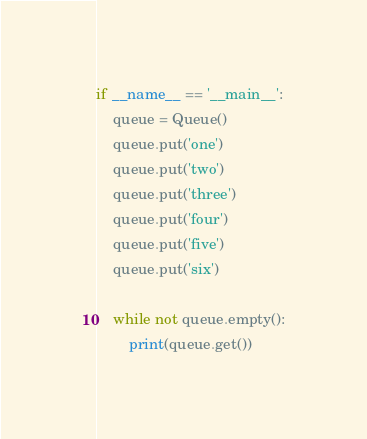<code> <loc_0><loc_0><loc_500><loc_500><_Python_>
if __name__ == '__main__':
    queue = Queue()
    queue.put('one')
    queue.put('two')
    queue.put('three')
    queue.put('four')
    queue.put('five')
    queue.put('six')

    while not queue.empty():
        print(queue.get())</code> 